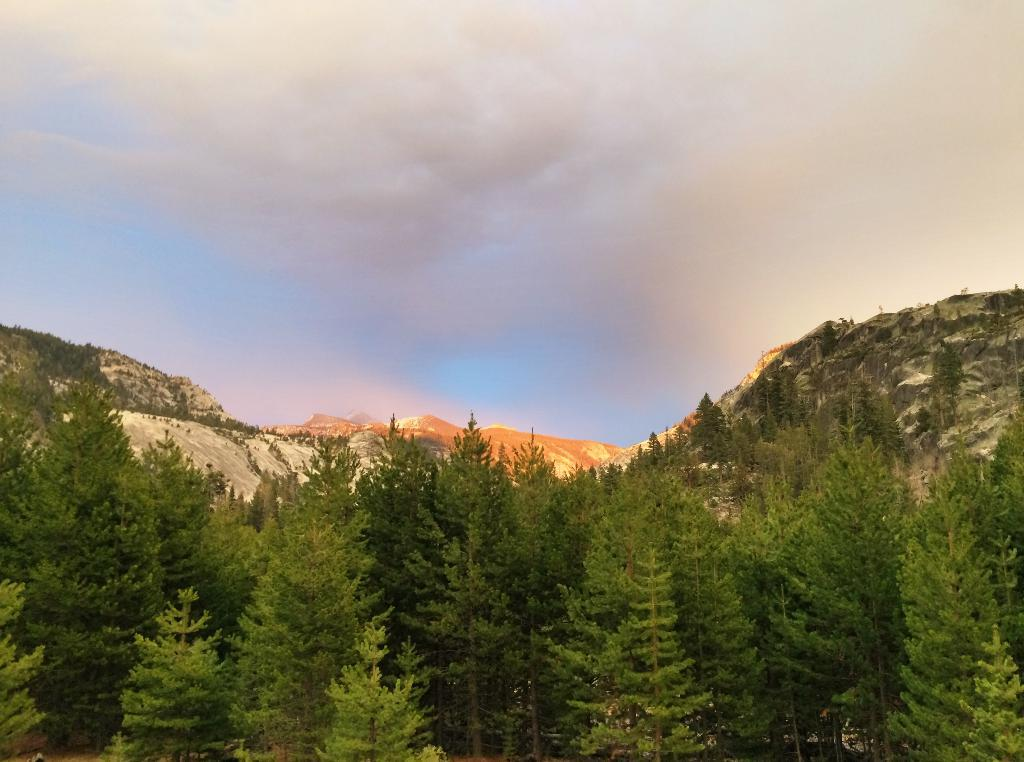What type of natural landform can be seen in the image? There are mountains in the image. What type of vegetation is present in the image? There are trees in the image. What part of the natural environment is visible in the background of the image? The sky is visible in the background of the image. What type of punishment is being handed out in the image? There is no indication of any punishment being handed out in the image; it features mountains, trees, and the sky. What type of pest can be seen in the image? There are no pests visible in the image; it features mountains, trees, and the sky. 